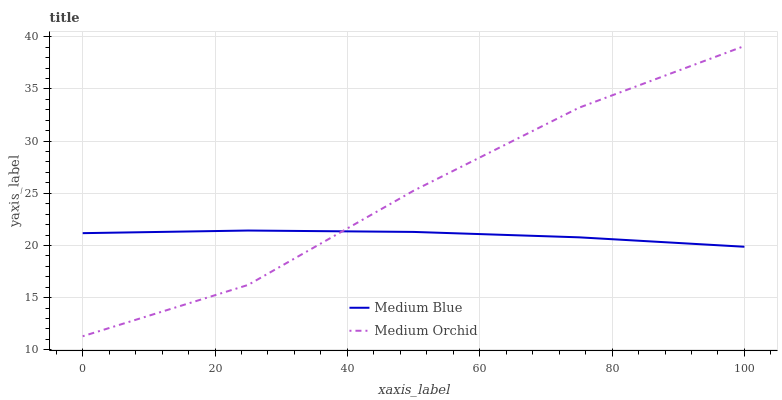Does Medium Blue have the minimum area under the curve?
Answer yes or no. Yes. Does Medium Orchid have the maximum area under the curve?
Answer yes or no. Yes. Does Medium Blue have the maximum area under the curve?
Answer yes or no. No. Is Medium Blue the smoothest?
Answer yes or no. Yes. Is Medium Orchid the roughest?
Answer yes or no. Yes. Is Medium Blue the roughest?
Answer yes or no. No. Does Medium Orchid have the lowest value?
Answer yes or no. Yes. Does Medium Blue have the lowest value?
Answer yes or no. No. Does Medium Orchid have the highest value?
Answer yes or no. Yes. Does Medium Blue have the highest value?
Answer yes or no. No. Does Medium Orchid intersect Medium Blue?
Answer yes or no. Yes. Is Medium Orchid less than Medium Blue?
Answer yes or no. No. Is Medium Orchid greater than Medium Blue?
Answer yes or no. No. 